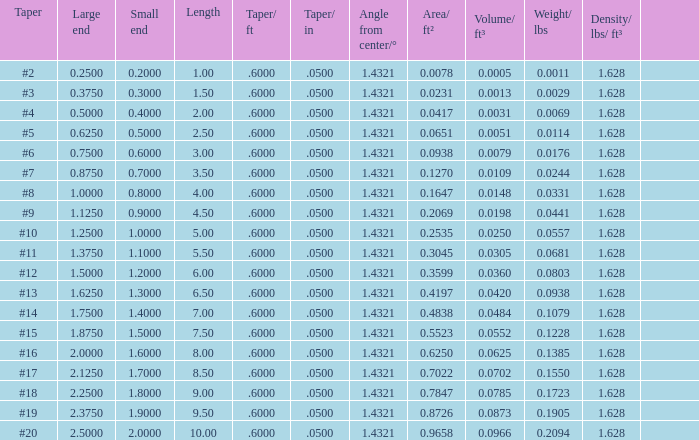Which Taper/ft that has a Large end smaller than 0.5, and a Taper of #2? 0.6. 